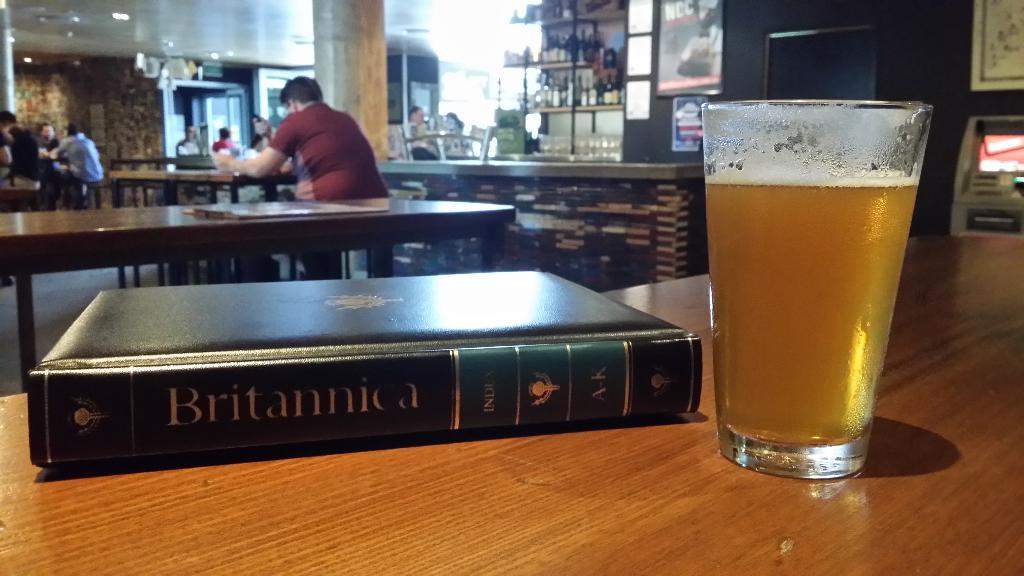<image>
Provide a brief description of the given image. a book that has Britannica written on it 